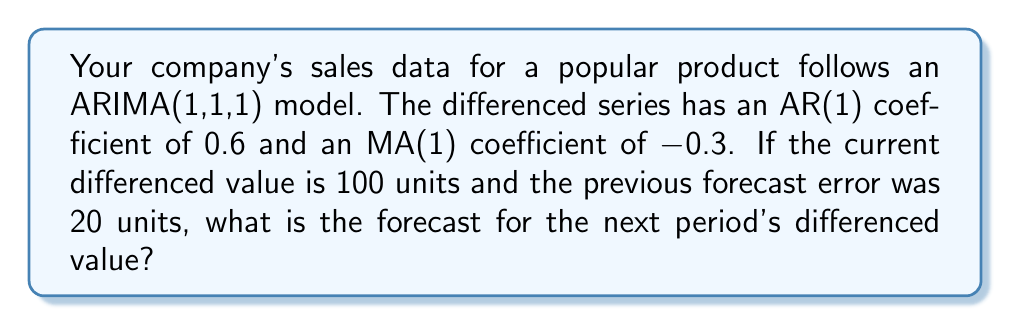What is the answer to this math problem? Let's approach this step-by-step:

1) An ARIMA(1,1,1) model for the differenced series can be written as:

   $$y_t = c + \phi_1 y_{t-1} + \epsilon_t - \theta_1 \epsilon_{t-1}$$

   where $y_t$ is the differenced series, $\phi_1$ is the AR(1) coefficient, $\theta_1$ is the MA(1) coefficient, and $\epsilon_t$ is the forecast error.

2) We're given:
   - $\phi_1 = 0.6$ (AR(1) coefficient)
   - $\theta_1 = -0.3$ (MA(1) coefficient)
   - $y_t = 100$ (current differenced value)
   - $\epsilon_t = 20$ (current forecast error)

3) To forecast the next period, we use:

   $$\hat{y}_{t+1} = c + \phi_1 y_t - \theta_1 \epsilon_t$$

4) We don't know the constant $c$, but for forecasting one step ahead, it doesn't affect the calculation as it's absorbed into the mean of the process. So we can simplify:

   $$\hat{y}_{t+1} = \phi_1 y_t - \theta_1 \epsilon_t$$

5) Plugging in our values:

   $$\hat{y}_{t+1} = 0.6 * 100 - (-0.3) * 20$$

6) Calculating:

   $$\hat{y}_{t+1} = 60 + 6 = 66$$

Thus, the forecast for the next period's differenced value is 66 units.
Answer: 66 units 